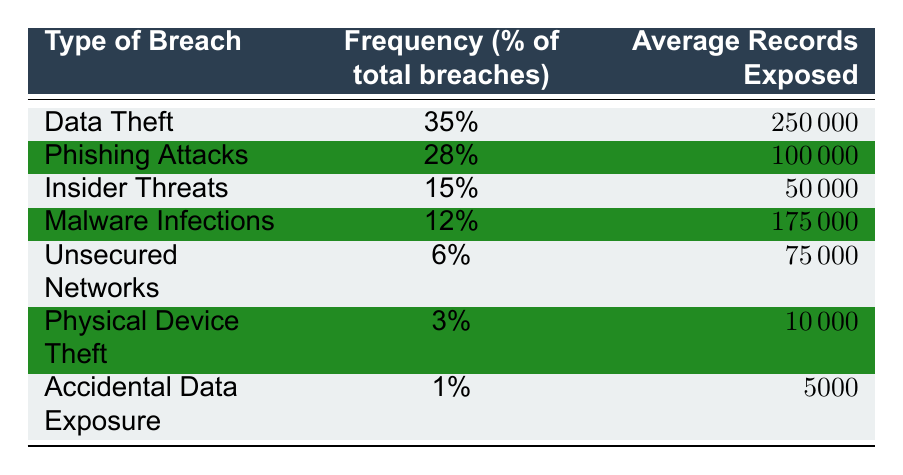What is the most frequent type of personal information breach? The table shows that the type of breach with the highest frequency is Data Theft, which accounts for 35% of total breaches.
Answer: Data Theft How many records on average are exposed in Phishing Attacks? According to the table, Phishing Attacks have an average of 100,000 records exposed.
Answer: 100,000 Do Insider Threats account for more than 20% of total breaches? The table indicates that Insider Threats represent 15% of total breaches, which is less than 20%.
Answer: No What is the average number of records exposed across all types of breaches? To find the average, first sum the average records exposed: 250,000 + 100,000 + 50,000 + 175,000 + 75,000 + 10,000 + 5,000 = 665,000. Then divide by 7 (the number of types): 665,000 / 7 = 95,000.
Answer: 95,000 Which type of breach has the least frequency? The table indicates that Accidental Data Exposure has the least frequency at 1%.
Answer: Accidental Data Exposure How much more frequent is Data Theft compared to Physical Device Theft? Data Theft is 35%, while Physical Device Theft is 3%. The difference is 35% - 3% = 32%.
Answer: 32% Is the frequency of Unsecured Networks greater than that of Malware Infections? The table shows that Unsecured Networks have a frequency of 6%, while Malware Infections have a frequency of 12%. Since 6% is less than 12%, the statement is false.
Answer: No What percentage of total breaches do Malware Infections and Insider Threats together account for? The frequency of Malware Infections is 12% and Insider Threats is 15%. Adding these together gives 12% + 15% = 27%.
Answer: 27% Which type of breach exposes, on average, the least number of records? According to the table, Physical Device Theft has the least average records exposed at 10,000.
Answer: Physical Device Theft 